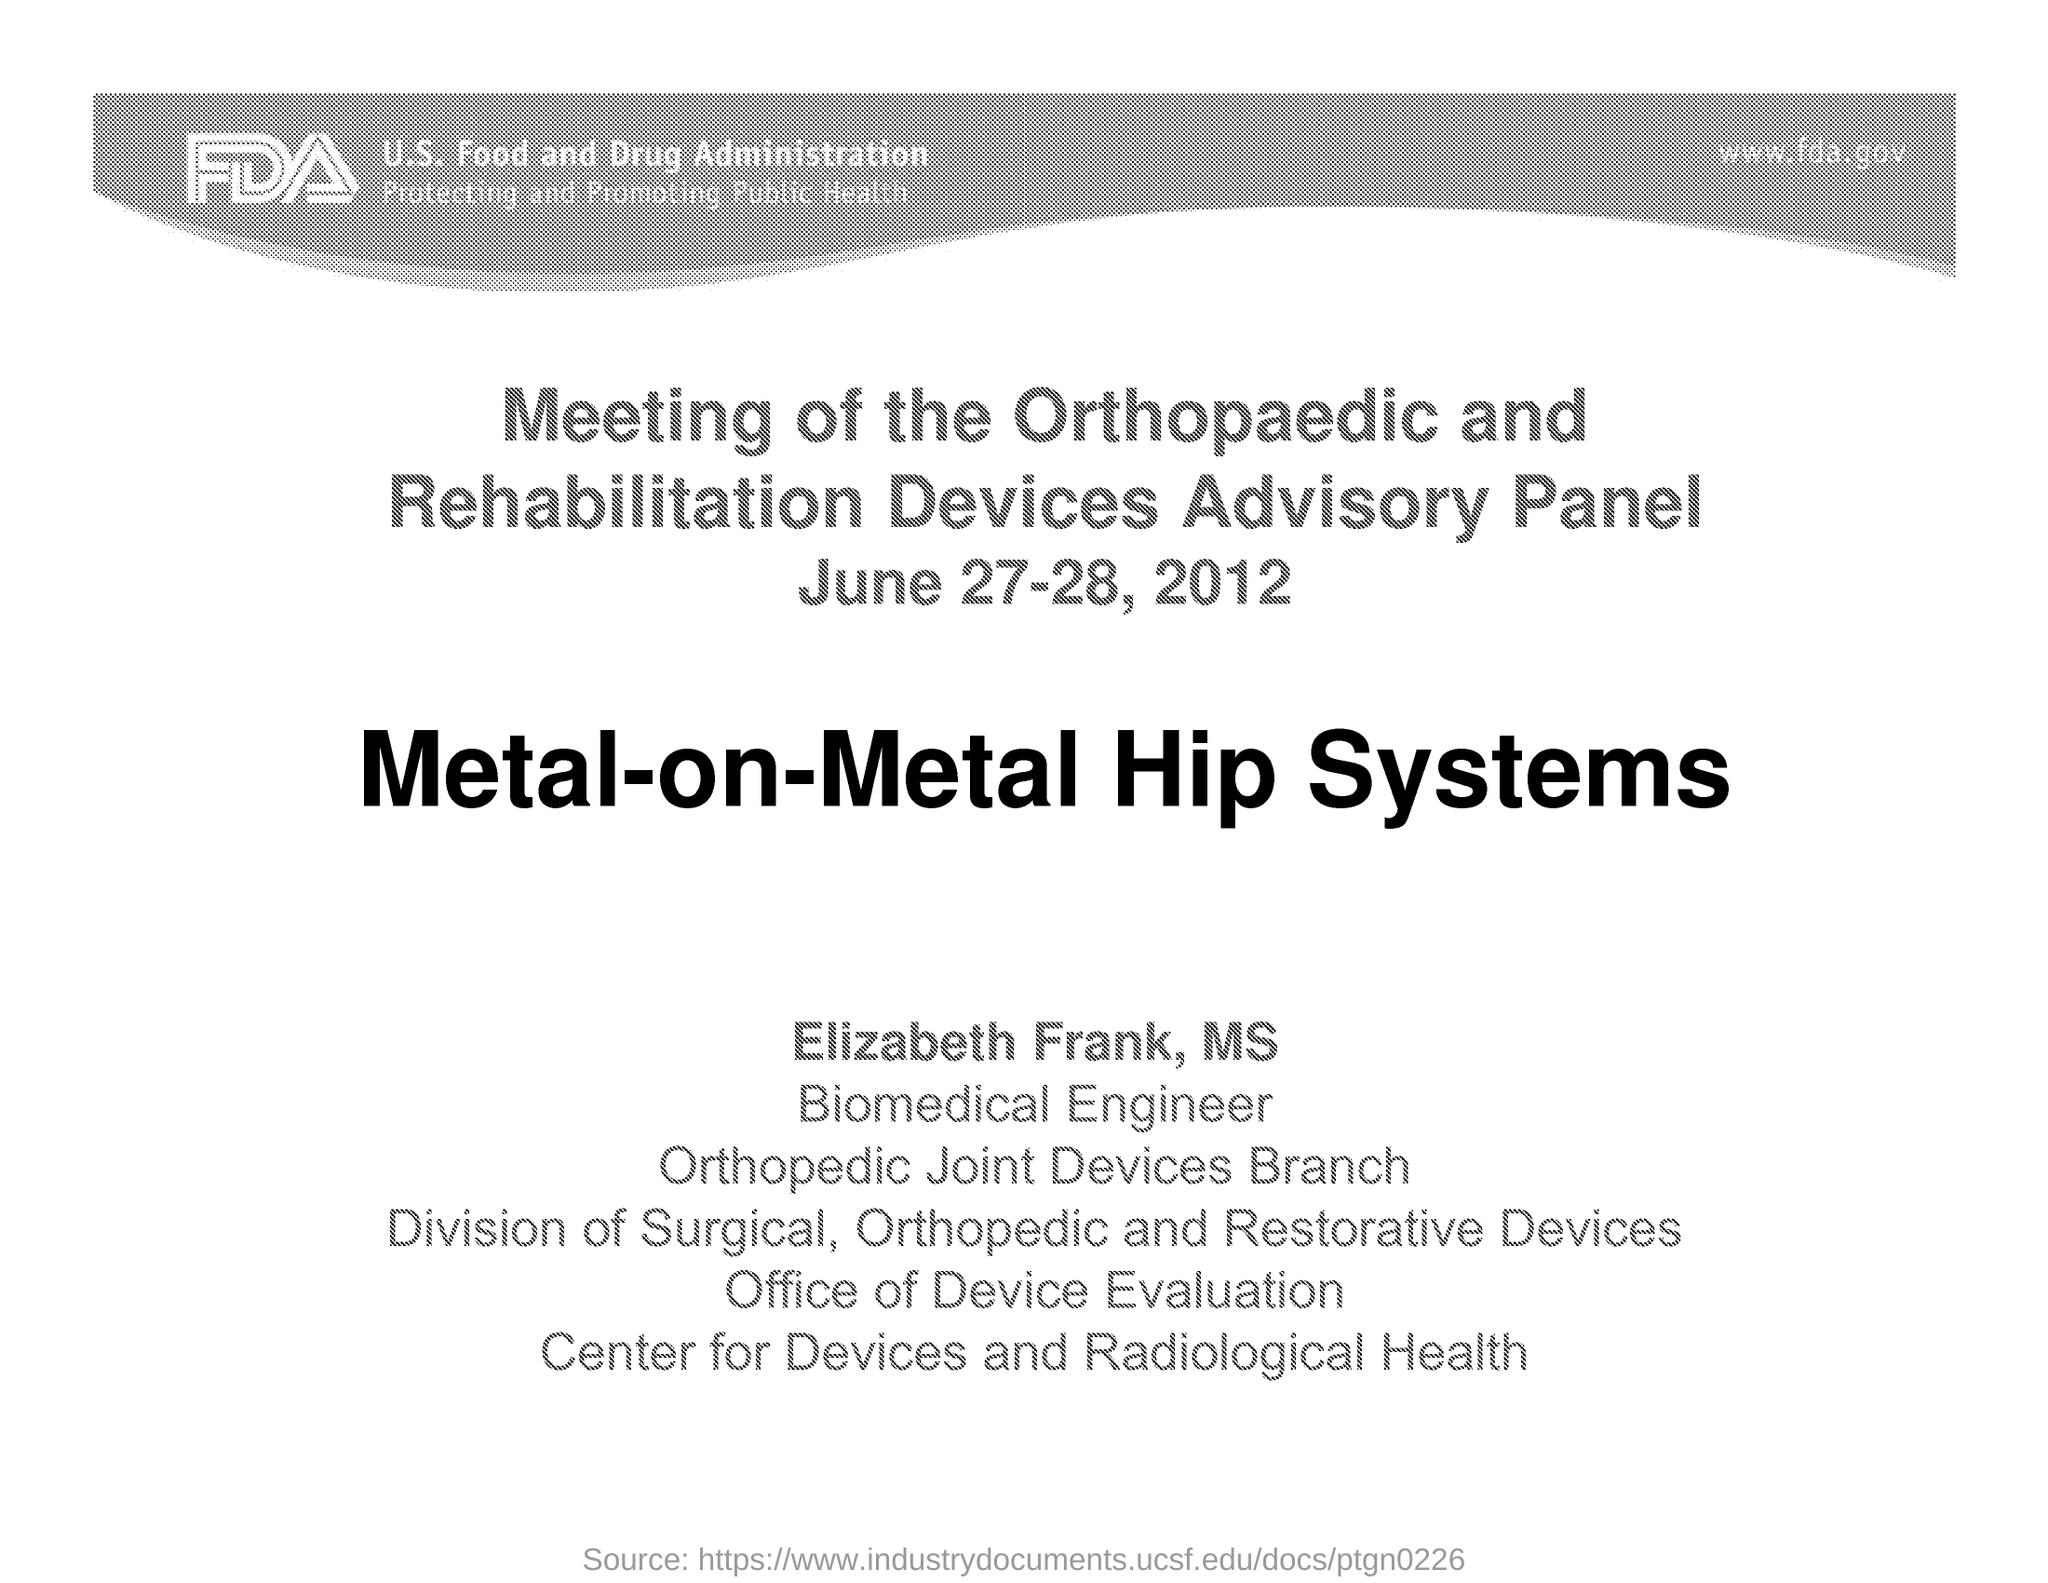Outline some significant characteristics in this image. The meeting of the Orthopaedic and Rehabilitation Devices Advisory Panel will be held on June 27-28, 2012. 